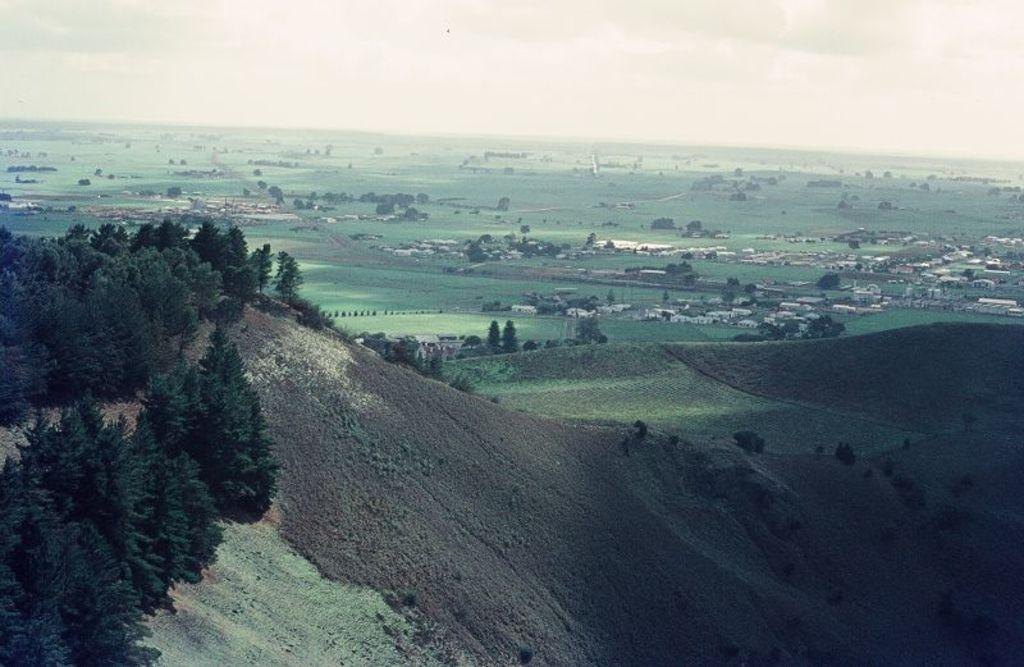What type of landscape is depicted at the bottom of the image? There are hills with grass and trees at the bottom of the image. What can be seen behind the hills in the image? There is ground with grass, trees, and buildings behind the hills. What is visible at the top of the image? The sky is visible at the top of the image. What type of glue is used to hold the hills together in the image? There is no glue present in the image; it is a natural landscape with hills, grass, and trees. What season is depicted in the image? The provided facts do not specify a season, so it cannot be determined from the image. 